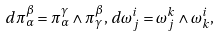<formula> <loc_0><loc_0><loc_500><loc_500>d \pi _ { \alpha } ^ { \beta } = \pi _ { \alpha } ^ { \gamma } \wedge \pi _ { \gamma } ^ { \beta } , \, d \omega _ { j } ^ { i } = \omega _ { j } ^ { k } \wedge \omega _ { k } ^ { i } ,</formula> 